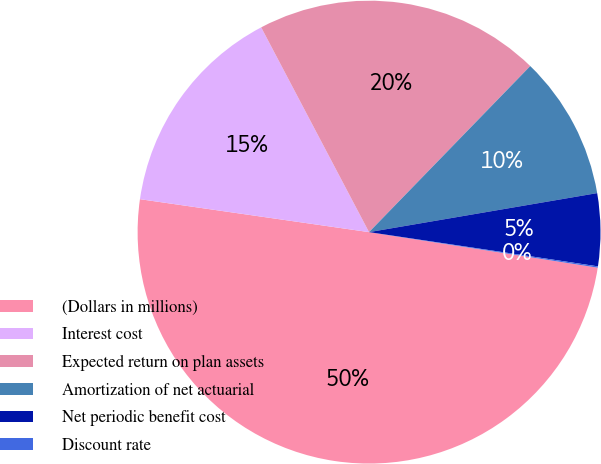Convert chart. <chart><loc_0><loc_0><loc_500><loc_500><pie_chart><fcel>(Dollars in millions)<fcel>Interest cost<fcel>Expected return on plan assets<fcel>Amortization of net actuarial<fcel>Net periodic benefit cost<fcel>Discount rate<nl><fcel>49.82%<fcel>15.01%<fcel>19.98%<fcel>10.04%<fcel>5.06%<fcel>0.09%<nl></chart> 